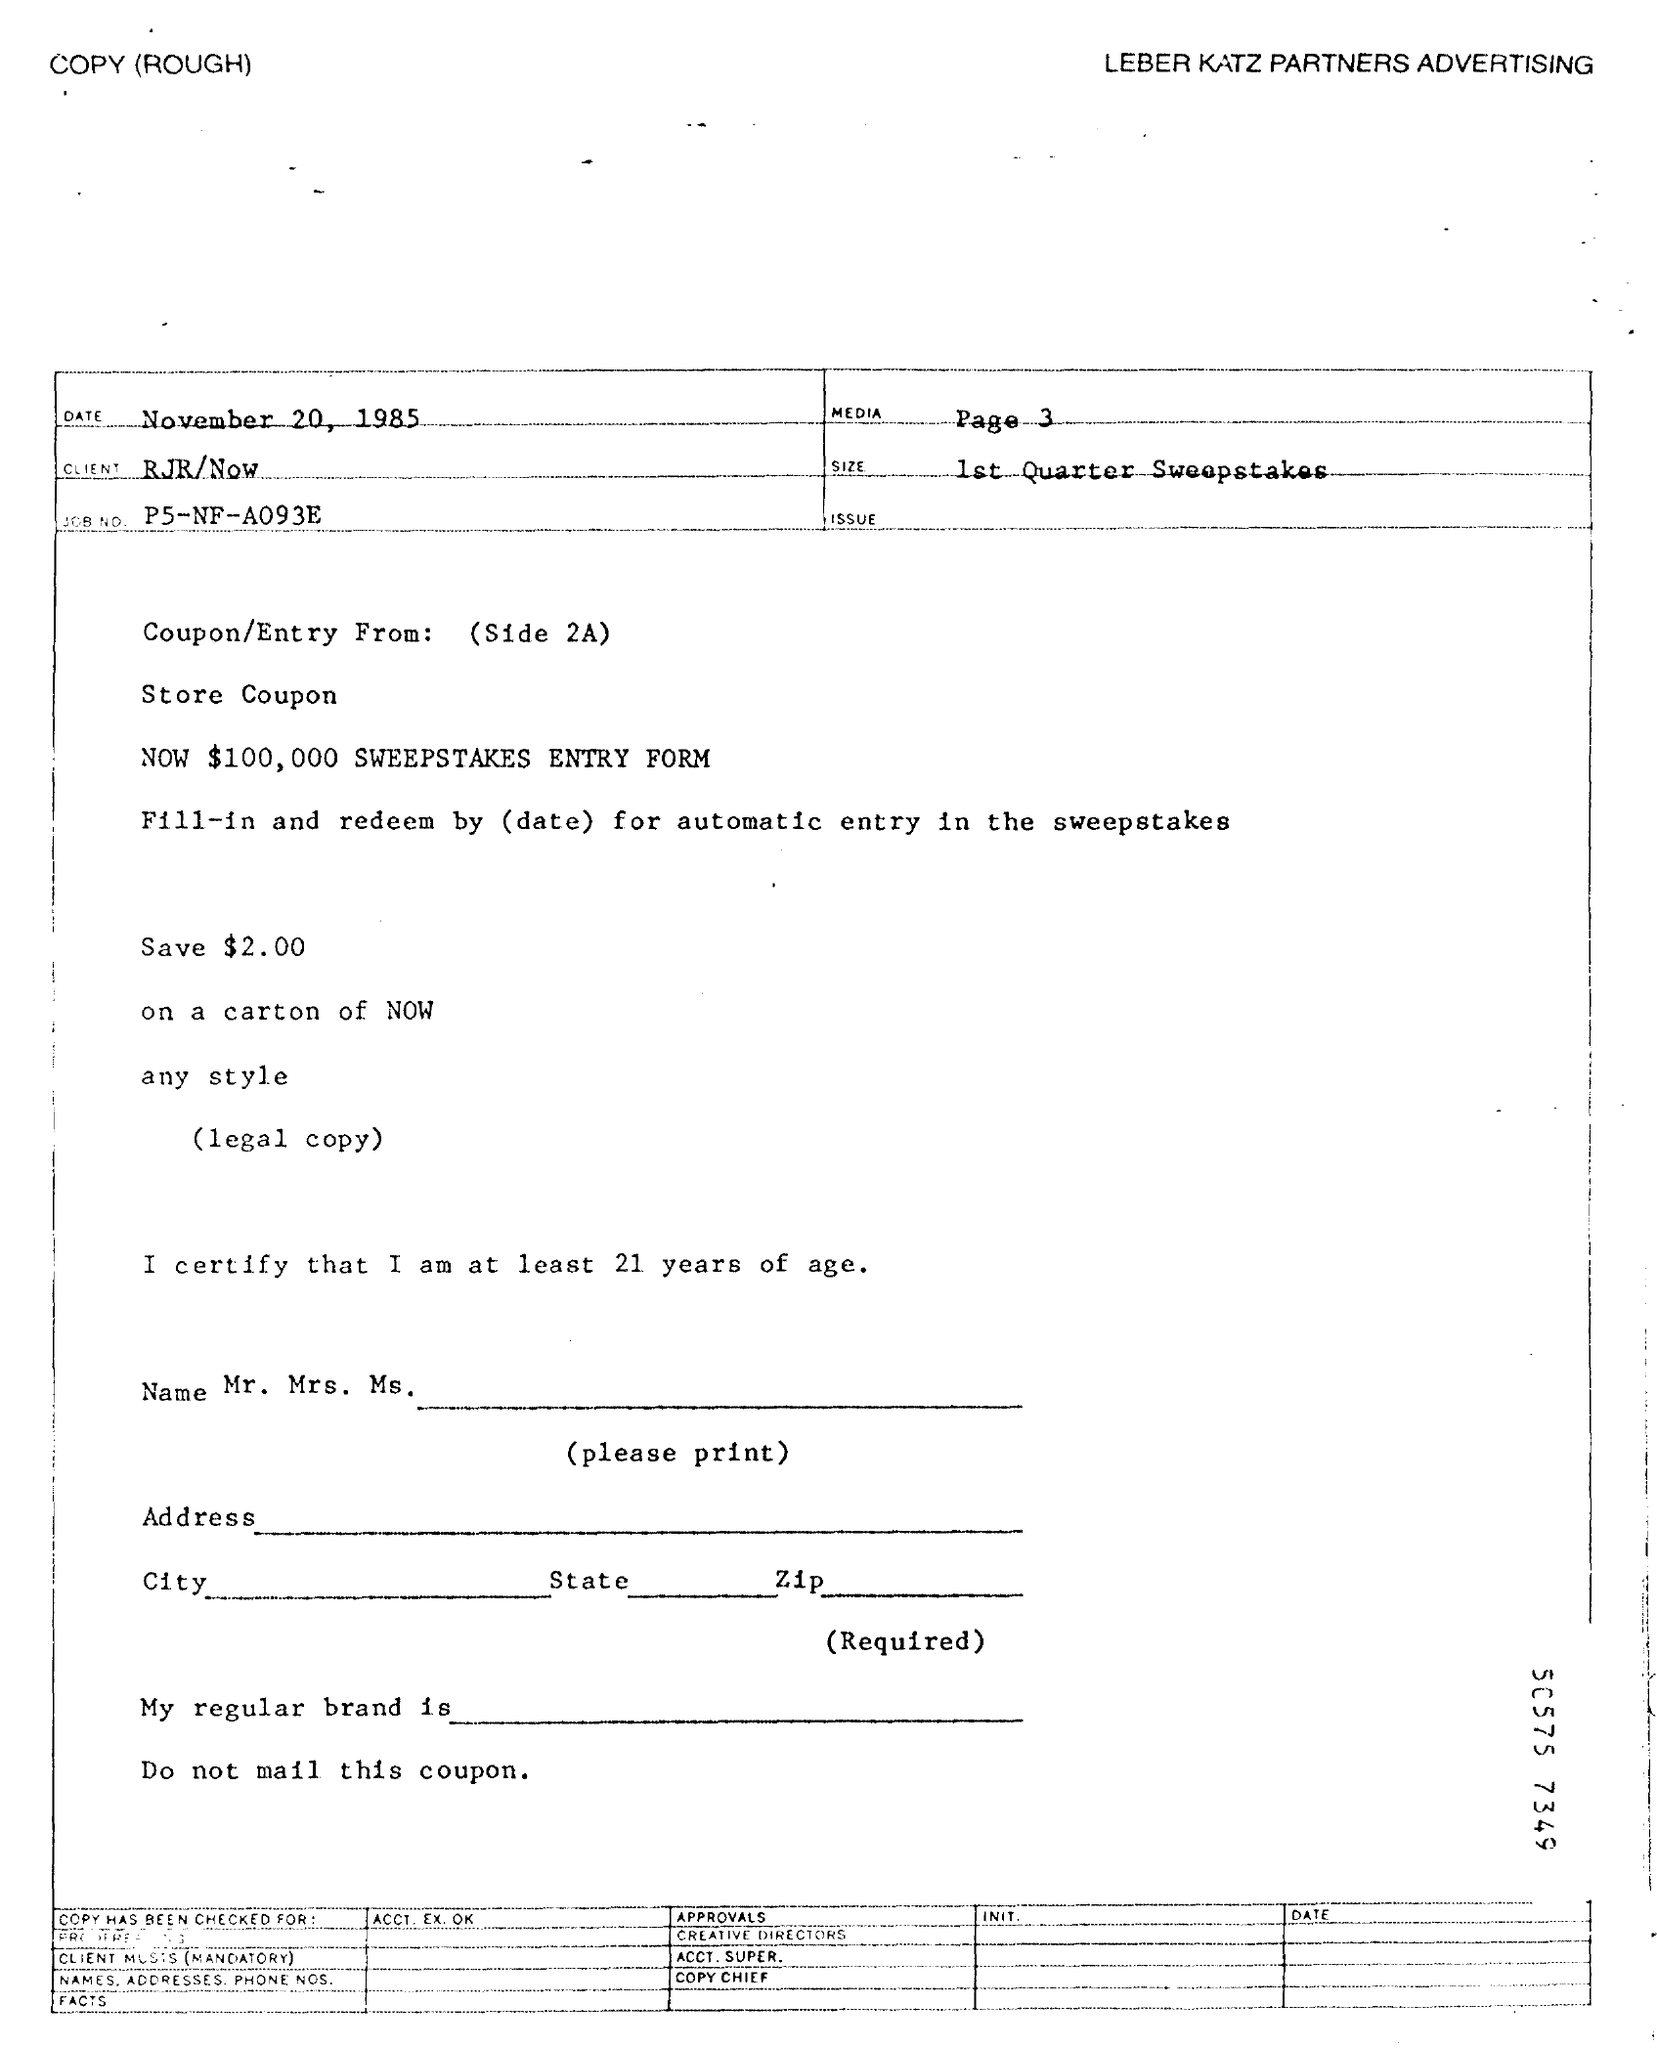What is the Date?
Ensure brevity in your answer.  November 20, 1985. What is the Job No.?
Offer a very short reply. P5-NF-A093E. What is the Media?
Give a very brief answer. Page 3. What is the Size?
Keep it short and to the point. 1st Quarter Sweepstakes. 